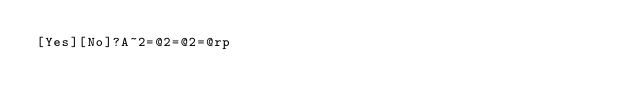<code> <loc_0><loc_0><loc_500><loc_500><_dc_>[Yes][No]?A~2=@2=@2=@rp</code> 